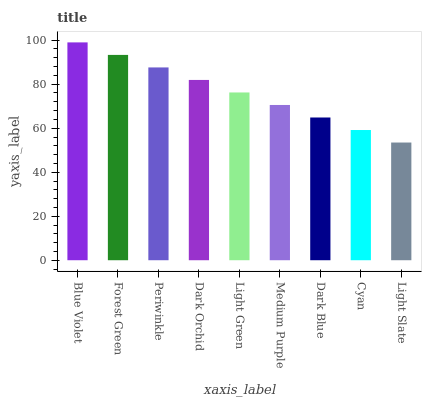Is Light Slate the minimum?
Answer yes or no. Yes. Is Blue Violet the maximum?
Answer yes or no. Yes. Is Forest Green the minimum?
Answer yes or no. No. Is Forest Green the maximum?
Answer yes or no. No. Is Blue Violet greater than Forest Green?
Answer yes or no. Yes. Is Forest Green less than Blue Violet?
Answer yes or no. Yes. Is Forest Green greater than Blue Violet?
Answer yes or no. No. Is Blue Violet less than Forest Green?
Answer yes or no. No. Is Light Green the high median?
Answer yes or no. Yes. Is Light Green the low median?
Answer yes or no. Yes. Is Forest Green the high median?
Answer yes or no. No. Is Periwinkle the low median?
Answer yes or no. No. 